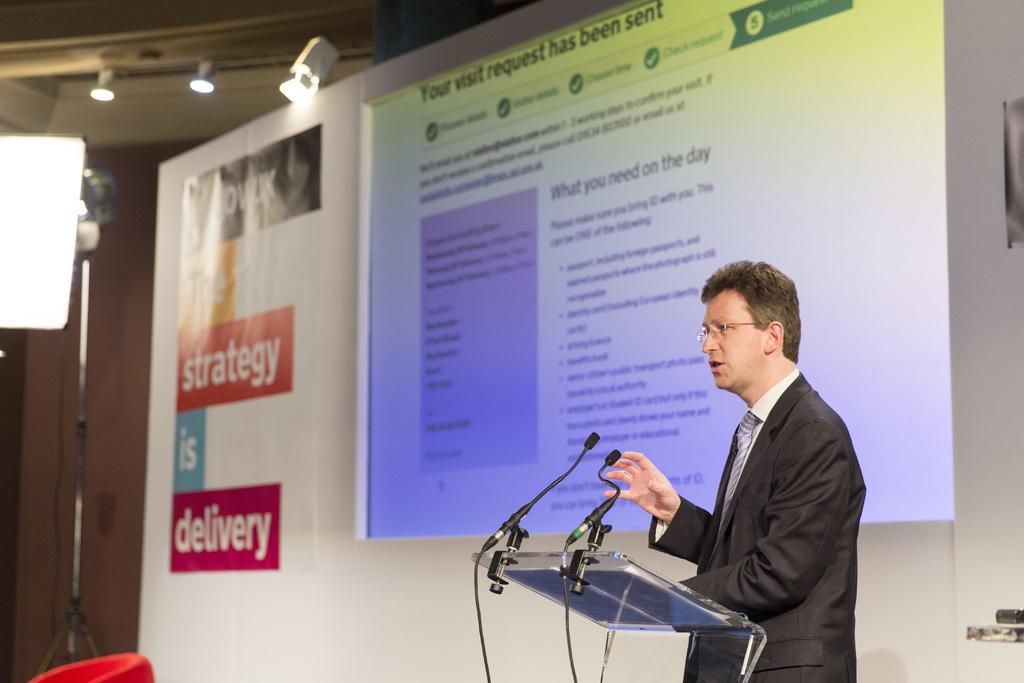Describe this image in one or two sentences. In this image, we can see a person standing and wearing glasses, in front of him, we can see a podium with mic stands. In the background, there is a screen and we can see a board and there are lights and we can see another stand and there is wall. At the bottom, we can see a red color object. 